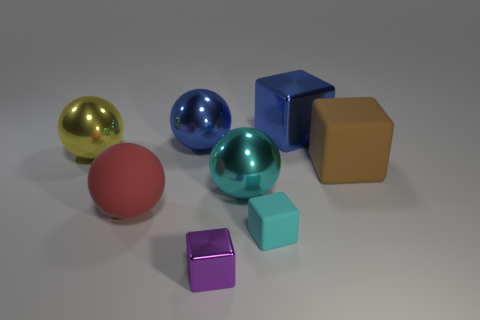Is there another shiny object of the same size as the brown thing?
Make the answer very short. Yes. What color is the matte thing that is the same shape as the large yellow metal thing?
Provide a succinct answer. Red. There is a metal cube right of the cyan metal object; is its size the same as the metal ball that is right of the purple block?
Ensure brevity in your answer.  Yes. Are there any small brown things that have the same shape as the large brown rubber object?
Your answer should be very brief. No. Is the number of large metal cubes that are right of the brown matte thing the same as the number of small purple metal cylinders?
Provide a short and direct response. Yes. Do the cyan shiny sphere and the cyan thing that is in front of the big red rubber sphere have the same size?
Your answer should be compact. No. What number of blue objects have the same material as the large cyan thing?
Provide a succinct answer. 2. Do the red matte sphere and the purple shiny block have the same size?
Offer a terse response. No. Is there any other thing that has the same color as the rubber ball?
Keep it short and to the point. No. The large object that is in front of the large brown rubber block and on the left side of the large cyan metallic sphere has what shape?
Your answer should be compact. Sphere. 